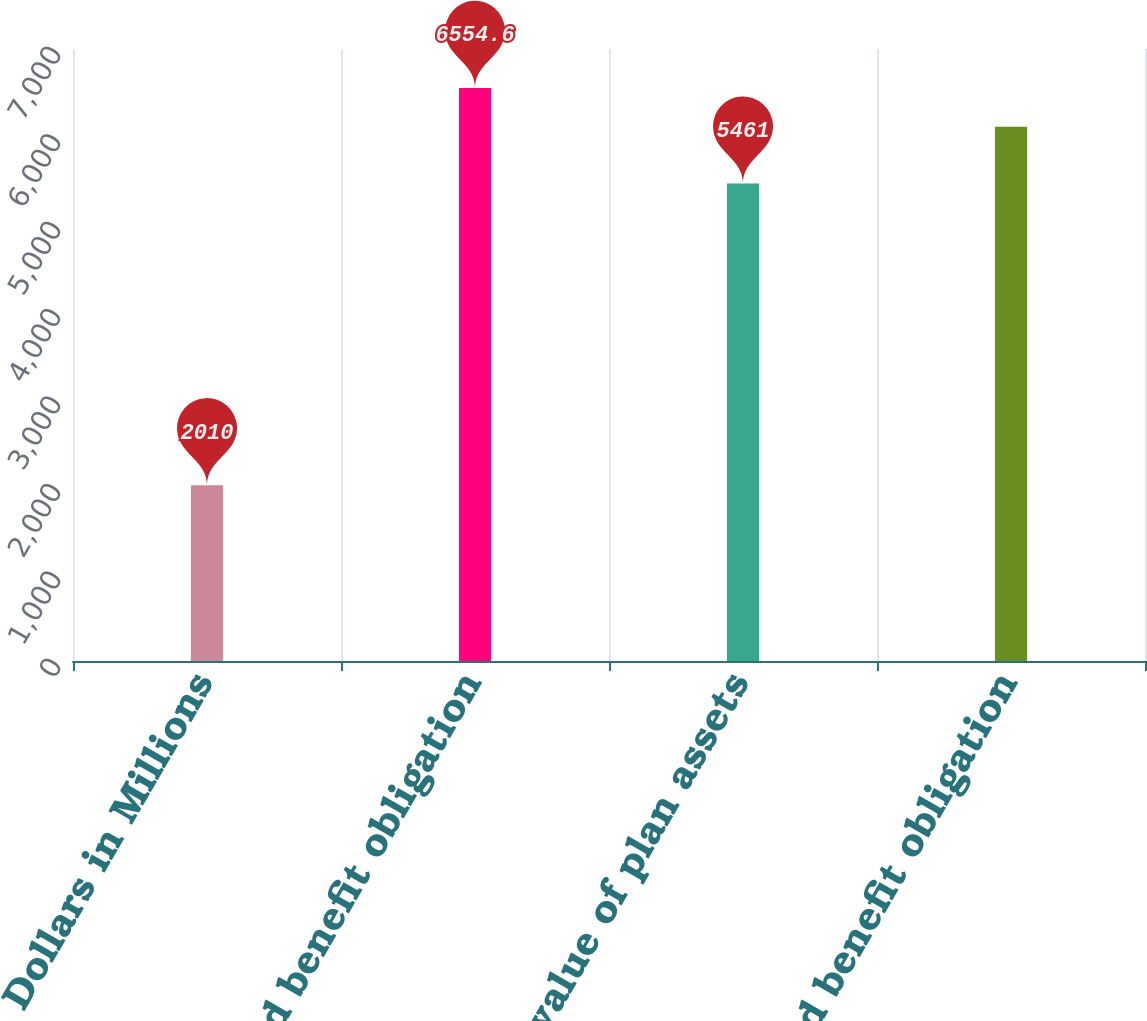Convert chart to OTSL. <chart><loc_0><loc_0><loc_500><loc_500><bar_chart><fcel>Dollars in Millions<fcel>Projected benefit obligation<fcel>Fair value of plan assets<fcel>Accumulated benefit obligation<nl><fcel>2010<fcel>6554.6<fcel>5461<fcel>6112<nl></chart> 